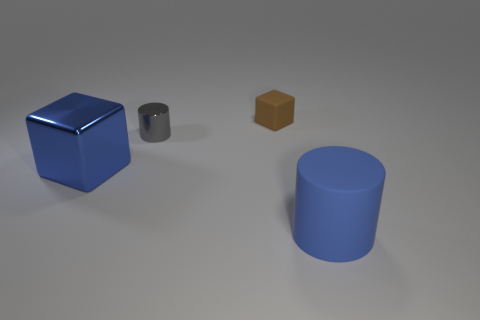Add 1 brown rubber objects. How many objects exist? 5 Subtract all purple metallic cylinders. Subtract all small shiny objects. How many objects are left? 3 Add 1 big metallic blocks. How many big metallic blocks are left? 2 Add 1 small cubes. How many small cubes exist? 2 Subtract 0 yellow cylinders. How many objects are left? 4 